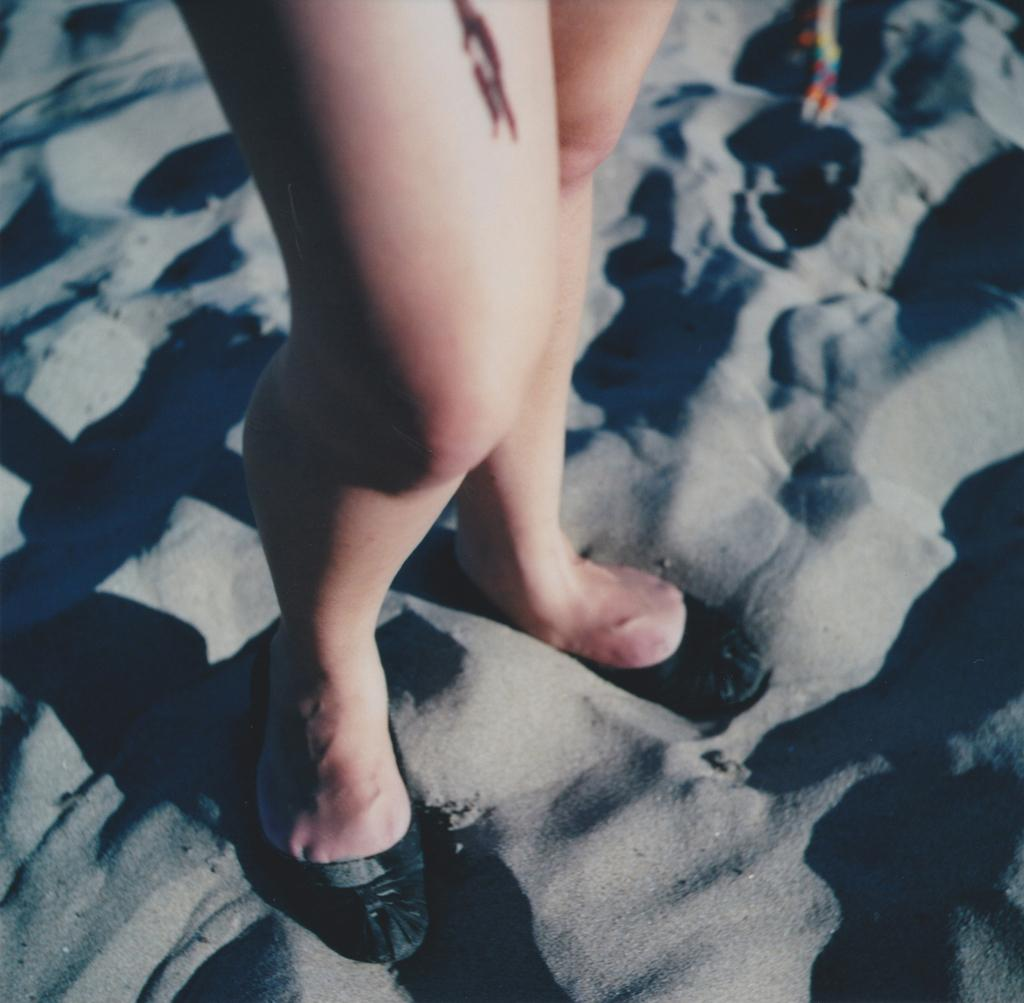What is present in the image? There is a person in the image. What part of the person's body is visible in the image? The person's legs are visible in the image. What type of terrain can be seen in the background of the image? There is sand visible in the background of the image. What type of caption is written on the sand in the image? There is no caption written on the sand in the image. What type of mint plant can be seen growing in the image? There is no mint plant present in the image. What type of cup is being used by the person in the image? There is no cup visible in the image. 